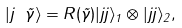<formula> <loc_0><loc_0><loc_500><loc_500>| j \text { } \vec { \gamma } \rangle = R ( \vec { \gamma } ) | j j \rangle _ { 1 } \otimes | j j \rangle _ { 2 } ,</formula> 